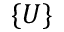Convert formula to latex. <formula><loc_0><loc_0><loc_500><loc_500>\{ U \}</formula> 